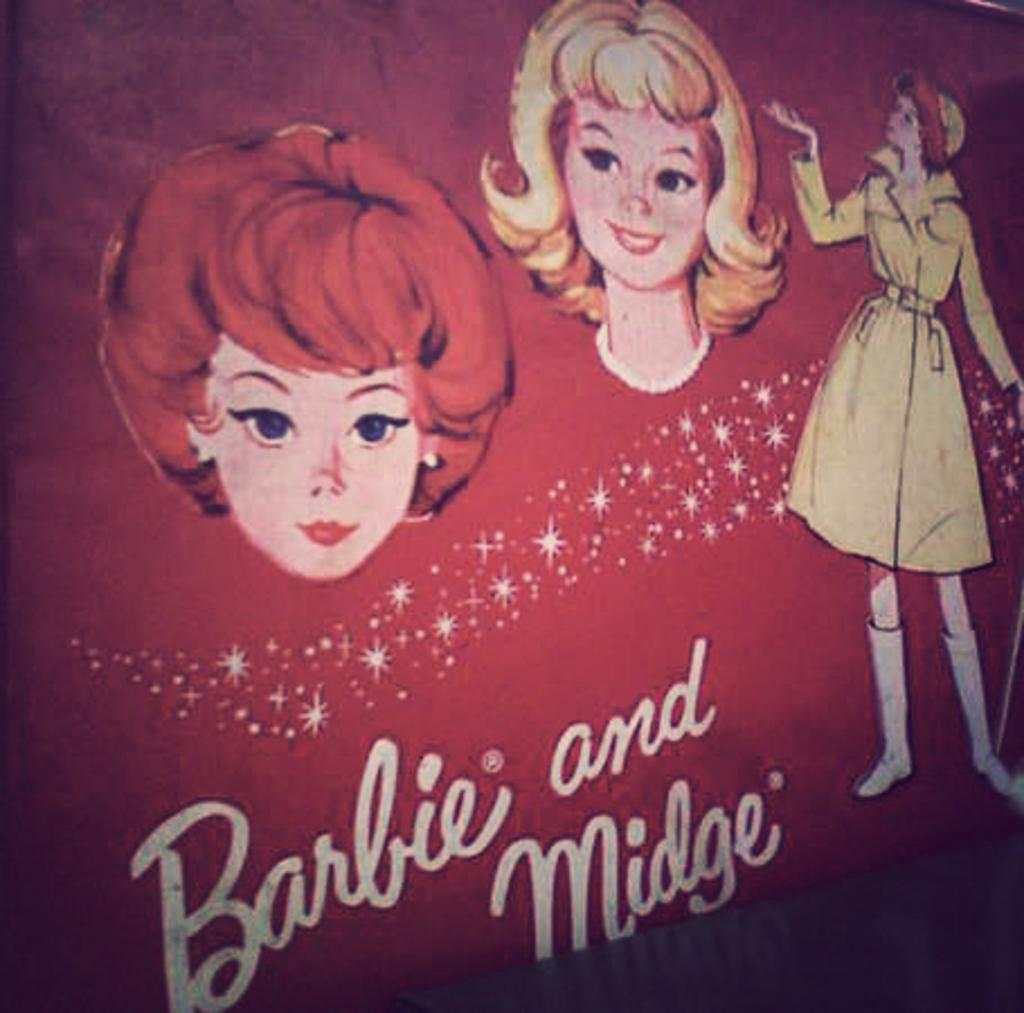What is present in the image that contains both text and images? There is a poster in the image that contains text and images. Can you describe the content of the poster? The poster contains text and images, but the specific content cannot be determined from the provided facts. What type of boot is being used to tie a knot in the image? There is no boot or knot present in the image; it only contains a poster with text and images. 